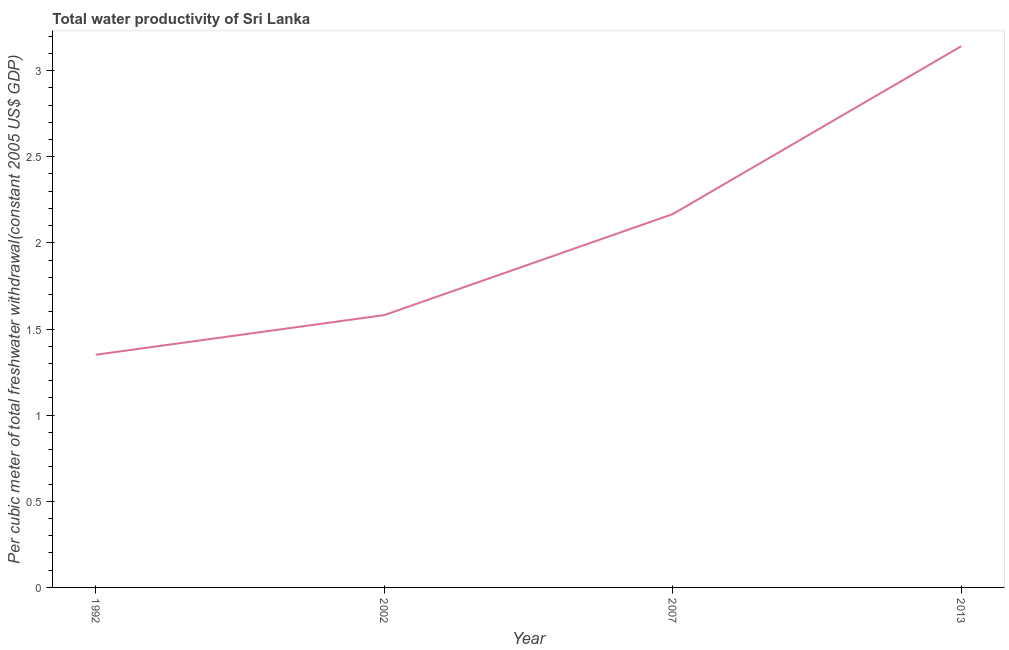What is the total water productivity in 1992?
Your answer should be compact. 1.35. Across all years, what is the maximum total water productivity?
Provide a succinct answer. 3.14. Across all years, what is the minimum total water productivity?
Keep it short and to the point. 1.35. In which year was the total water productivity maximum?
Your response must be concise. 2013. What is the sum of the total water productivity?
Provide a succinct answer. 8.24. What is the difference between the total water productivity in 1992 and 2013?
Give a very brief answer. -1.79. What is the average total water productivity per year?
Ensure brevity in your answer.  2.06. What is the median total water productivity?
Give a very brief answer. 1.87. What is the ratio of the total water productivity in 1992 to that in 2002?
Your response must be concise. 0.85. Is the total water productivity in 2002 less than that in 2013?
Provide a succinct answer. Yes. Is the difference between the total water productivity in 2002 and 2013 greater than the difference between any two years?
Offer a terse response. No. What is the difference between the highest and the second highest total water productivity?
Offer a very short reply. 0.97. What is the difference between the highest and the lowest total water productivity?
Provide a succinct answer. 1.79. Does the total water productivity monotonically increase over the years?
Ensure brevity in your answer.  Yes. How many lines are there?
Ensure brevity in your answer.  1. What is the difference between two consecutive major ticks on the Y-axis?
Offer a very short reply. 0.5. What is the title of the graph?
Offer a terse response. Total water productivity of Sri Lanka. What is the label or title of the Y-axis?
Offer a very short reply. Per cubic meter of total freshwater withdrawal(constant 2005 US$ GDP). What is the Per cubic meter of total freshwater withdrawal(constant 2005 US$ GDP) in 1992?
Your answer should be very brief. 1.35. What is the Per cubic meter of total freshwater withdrawal(constant 2005 US$ GDP) of 2002?
Offer a terse response. 1.58. What is the Per cubic meter of total freshwater withdrawal(constant 2005 US$ GDP) of 2007?
Keep it short and to the point. 2.17. What is the Per cubic meter of total freshwater withdrawal(constant 2005 US$ GDP) of 2013?
Your answer should be very brief. 3.14. What is the difference between the Per cubic meter of total freshwater withdrawal(constant 2005 US$ GDP) in 1992 and 2002?
Provide a succinct answer. -0.23. What is the difference between the Per cubic meter of total freshwater withdrawal(constant 2005 US$ GDP) in 1992 and 2007?
Give a very brief answer. -0.82. What is the difference between the Per cubic meter of total freshwater withdrawal(constant 2005 US$ GDP) in 1992 and 2013?
Give a very brief answer. -1.79. What is the difference between the Per cubic meter of total freshwater withdrawal(constant 2005 US$ GDP) in 2002 and 2007?
Give a very brief answer. -0.59. What is the difference between the Per cubic meter of total freshwater withdrawal(constant 2005 US$ GDP) in 2002 and 2013?
Your answer should be very brief. -1.56. What is the difference between the Per cubic meter of total freshwater withdrawal(constant 2005 US$ GDP) in 2007 and 2013?
Give a very brief answer. -0.97. What is the ratio of the Per cubic meter of total freshwater withdrawal(constant 2005 US$ GDP) in 1992 to that in 2002?
Ensure brevity in your answer.  0.85. What is the ratio of the Per cubic meter of total freshwater withdrawal(constant 2005 US$ GDP) in 1992 to that in 2007?
Your response must be concise. 0.62. What is the ratio of the Per cubic meter of total freshwater withdrawal(constant 2005 US$ GDP) in 1992 to that in 2013?
Your response must be concise. 0.43. What is the ratio of the Per cubic meter of total freshwater withdrawal(constant 2005 US$ GDP) in 2002 to that in 2007?
Make the answer very short. 0.73. What is the ratio of the Per cubic meter of total freshwater withdrawal(constant 2005 US$ GDP) in 2002 to that in 2013?
Provide a short and direct response. 0.5. What is the ratio of the Per cubic meter of total freshwater withdrawal(constant 2005 US$ GDP) in 2007 to that in 2013?
Provide a short and direct response. 0.69. 